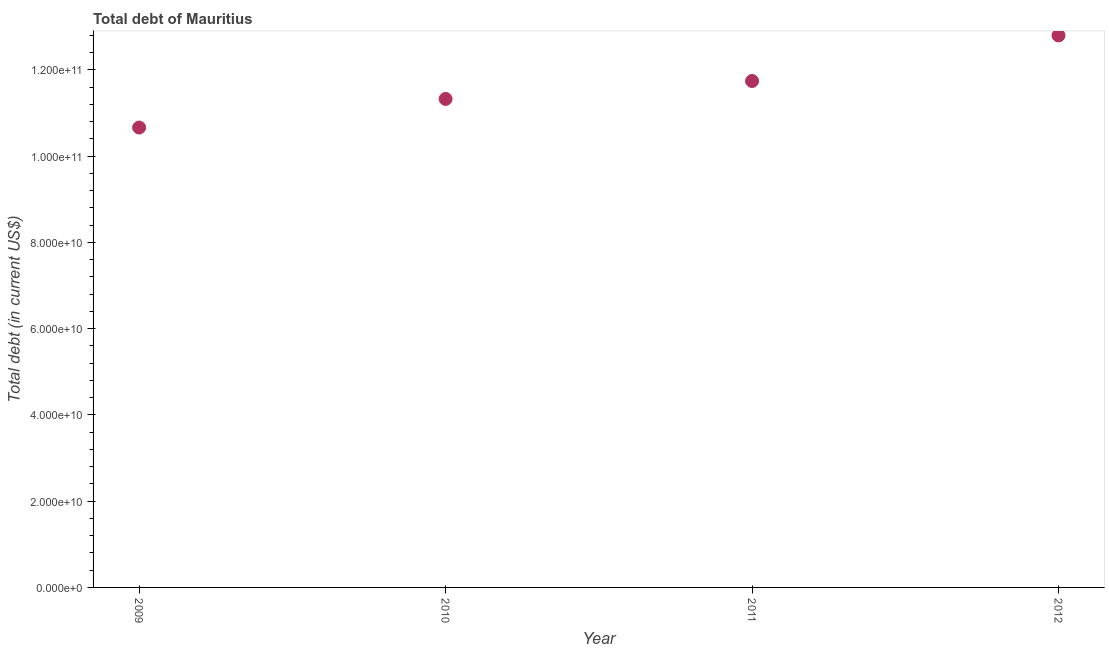What is the total debt in 2011?
Keep it short and to the point. 1.17e+11. Across all years, what is the maximum total debt?
Your answer should be compact. 1.28e+11. Across all years, what is the minimum total debt?
Offer a very short reply. 1.07e+11. What is the sum of the total debt?
Offer a very short reply. 4.65e+11. What is the difference between the total debt in 2010 and 2012?
Keep it short and to the point. -1.47e+1. What is the average total debt per year?
Ensure brevity in your answer.  1.16e+11. What is the median total debt?
Offer a terse response. 1.15e+11. Do a majority of the years between 2009 and 2011 (inclusive) have total debt greater than 60000000000 US$?
Ensure brevity in your answer.  Yes. What is the ratio of the total debt in 2010 to that in 2012?
Make the answer very short. 0.88. Is the difference between the total debt in 2010 and 2012 greater than the difference between any two years?
Provide a short and direct response. No. What is the difference between the highest and the second highest total debt?
Give a very brief answer. 1.06e+1. Is the sum of the total debt in 2009 and 2012 greater than the maximum total debt across all years?
Your answer should be very brief. Yes. What is the difference between the highest and the lowest total debt?
Provide a succinct answer. 2.14e+1. In how many years, is the total debt greater than the average total debt taken over all years?
Provide a short and direct response. 2. Does the total debt monotonically increase over the years?
Ensure brevity in your answer.  Yes. How many years are there in the graph?
Offer a terse response. 4. Are the values on the major ticks of Y-axis written in scientific E-notation?
Your answer should be very brief. Yes. Does the graph contain grids?
Provide a short and direct response. No. What is the title of the graph?
Give a very brief answer. Total debt of Mauritius. What is the label or title of the Y-axis?
Offer a very short reply. Total debt (in current US$). What is the Total debt (in current US$) in 2009?
Provide a short and direct response. 1.07e+11. What is the Total debt (in current US$) in 2010?
Make the answer very short. 1.13e+11. What is the Total debt (in current US$) in 2011?
Provide a short and direct response. 1.17e+11. What is the Total debt (in current US$) in 2012?
Offer a very short reply. 1.28e+11. What is the difference between the Total debt (in current US$) in 2009 and 2010?
Provide a succinct answer. -6.63e+09. What is the difference between the Total debt (in current US$) in 2009 and 2011?
Your answer should be very brief. -1.08e+1. What is the difference between the Total debt (in current US$) in 2009 and 2012?
Your answer should be very brief. -2.14e+1. What is the difference between the Total debt (in current US$) in 2010 and 2011?
Your answer should be very brief. -4.16e+09. What is the difference between the Total debt (in current US$) in 2010 and 2012?
Your answer should be compact. -1.47e+1. What is the difference between the Total debt (in current US$) in 2011 and 2012?
Provide a short and direct response. -1.06e+1. What is the ratio of the Total debt (in current US$) in 2009 to that in 2010?
Ensure brevity in your answer.  0.94. What is the ratio of the Total debt (in current US$) in 2009 to that in 2011?
Make the answer very short. 0.91. What is the ratio of the Total debt (in current US$) in 2009 to that in 2012?
Offer a very short reply. 0.83. What is the ratio of the Total debt (in current US$) in 2010 to that in 2011?
Your response must be concise. 0.96. What is the ratio of the Total debt (in current US$) in 2010 to that in 2012?
Make the answer very short. 0.89. What is the ratio of the Total debt (in current US$) in 2011 to that in 2012?
Ensure brevity in your answer.  0.92. 